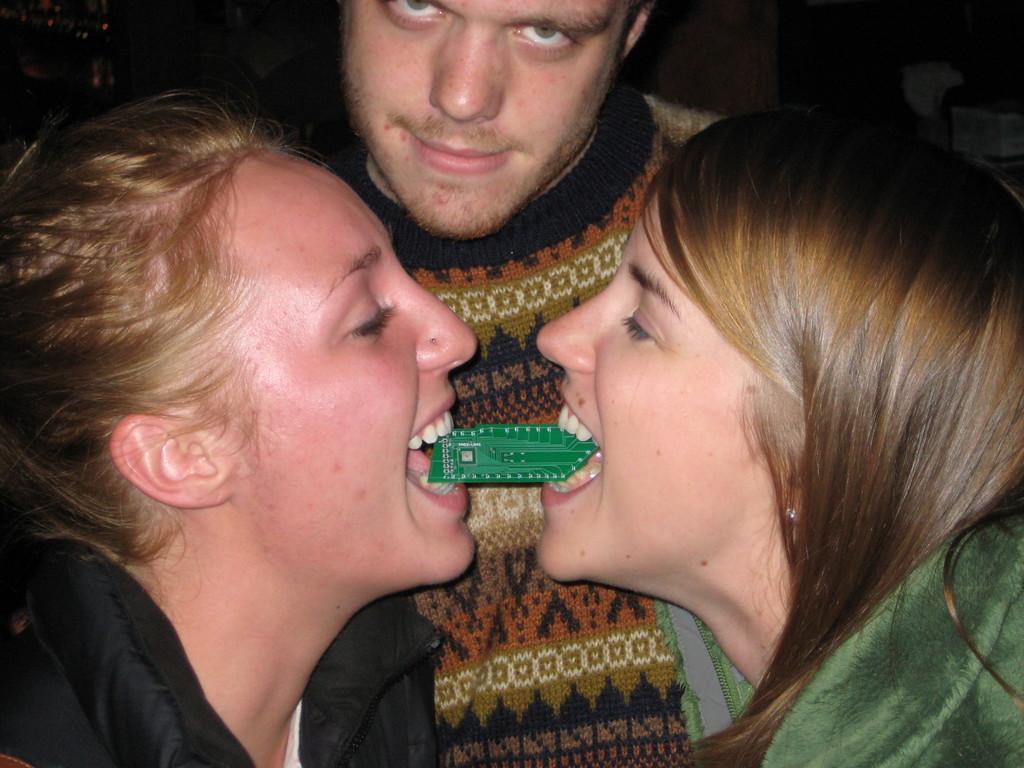Describe this image in one or two sentences. In this image, I can see a man and there are two women holding an object with their mouths. There is a dark background. 